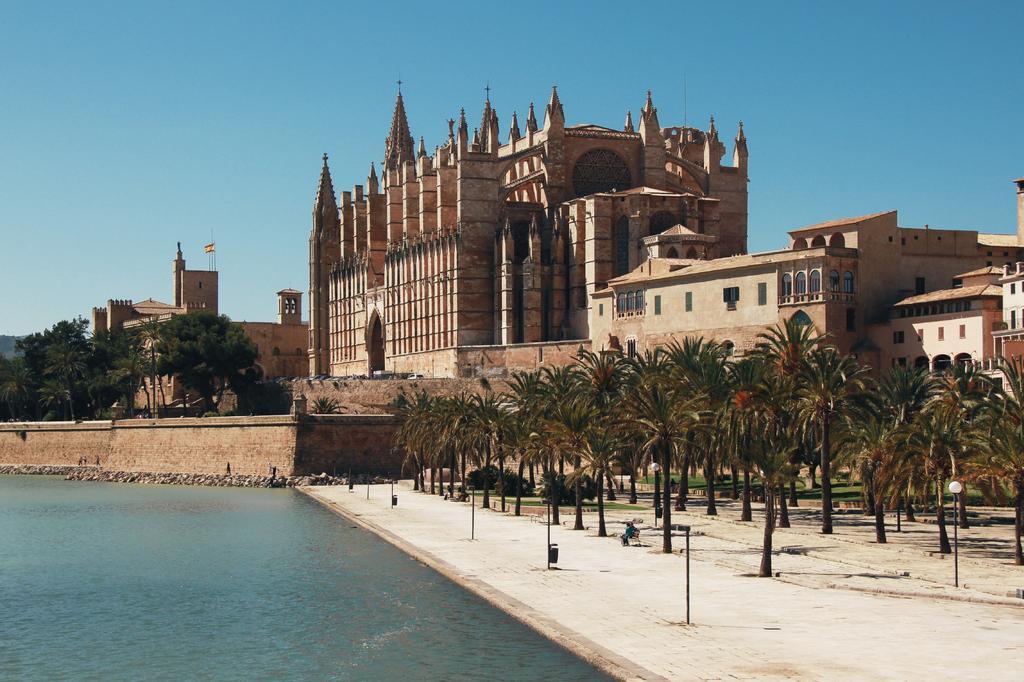Please provide a concise description of this image. In this picture we can see trees, water, buildings with windows, flag and in the background we can see the sky. 